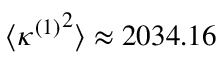<formula> <loc_0><loc_0><loc_500><loc_500>\langle { \kappa ^ { ( 1 ) } } ^ { 2 } \rangle \approx 2 0 3 4 . 1 6</formula> 